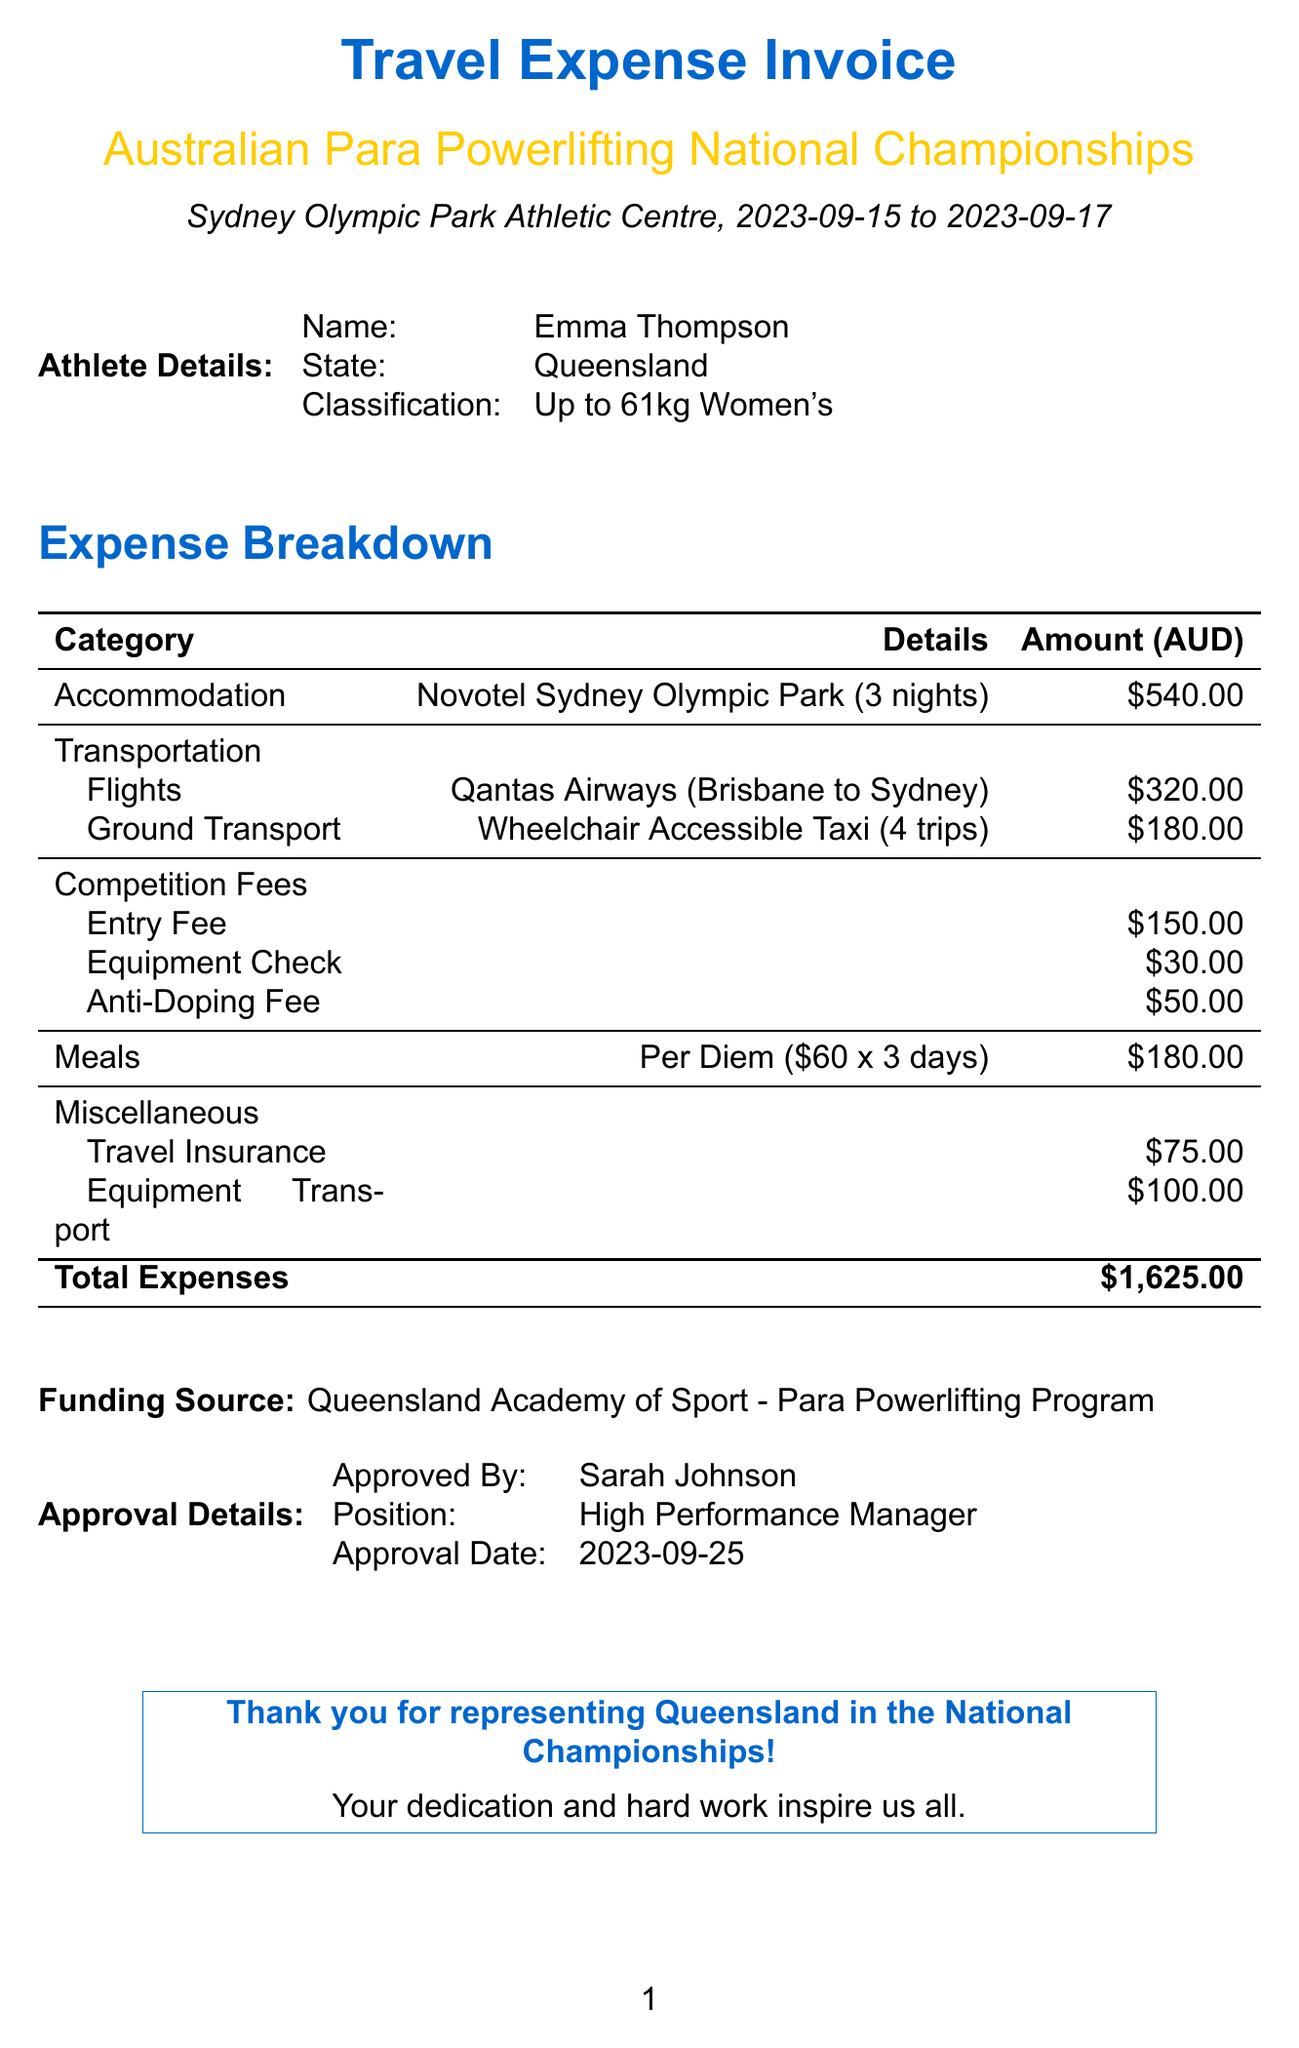what is the name of the event? The event is specifically identified as the "Australian Para Powerlifting National Championships" in the document.
Answer: Australian Para Powerlifting National Championships who approved the invoice? The invoice was approved by Sarah Johnson, as mentioned in the approval details section.
Answer: Sarah Johnson what city hosted the competition? The city where the competition took place is stated in the event location as Sydney.
Answer: Sydney how many nights was accommodation booked for? The document clearly states that the accommodation was for 3 nights at the hotel.
Answer: 3 what is the total cost of competition fees? The total competition fees are the sum of the entry fee, equipment check, and anti-doping fee, which is given in the document.
Answer: 230 how much was spent on transportation in total? The total transportation cost is provided as a breakdown of flights and ground transport, aggregating to a specific amount.
Answer: 500 what is the total amount of travel expenses? The document provides a total expenses section that aggregates all categories into a single figure.
Answer: 1625 which hotel was the accommodation in? The document lists the hotel where accommodation was provided as Novotel Sydney Olympic Park.
Answer: Novotel Sydney Olympic Park what is the purpose of the funding source mentioned? The funding source indicated is for the Queensland Academy of Sport - Para Powerlifting Program, which supports athletes in their expenses for competitions.
Answer: Queensland Academy of Sport - Para Powerlifting Program 